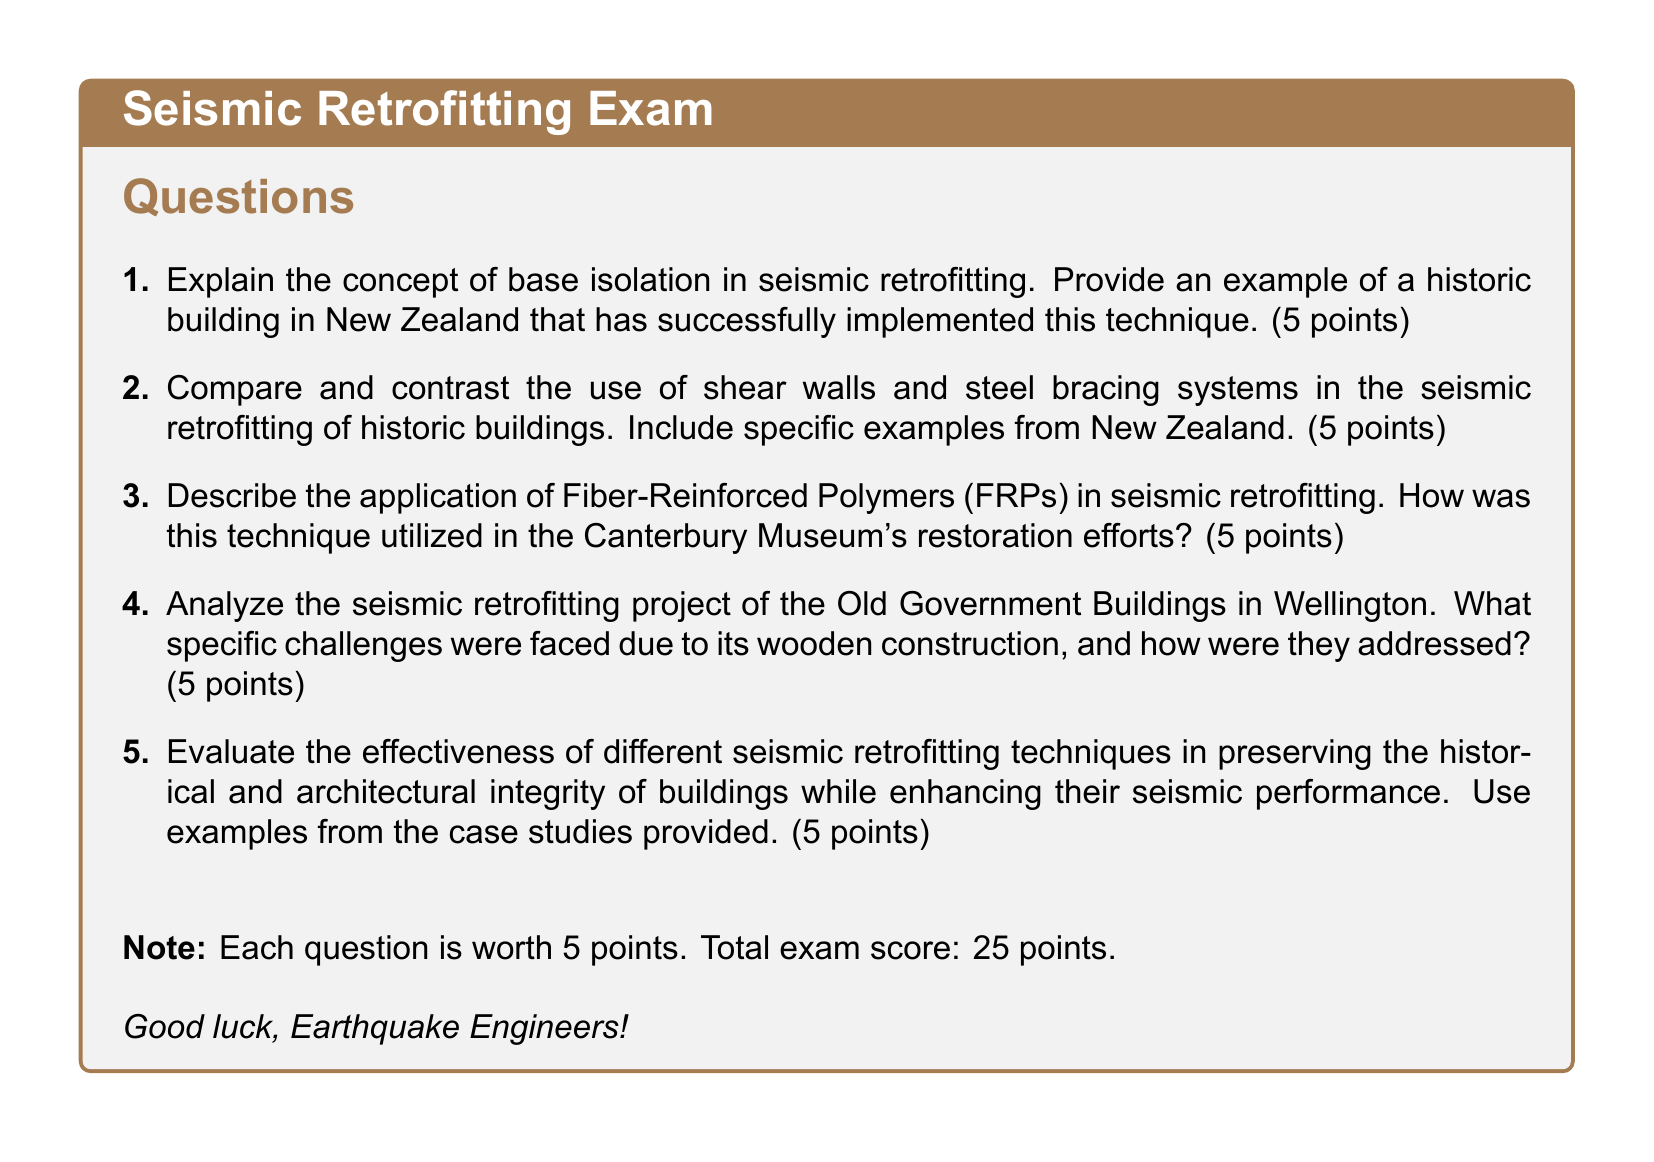What is the total score for the exam? The total exam score is calculated based on the points assigned to each question, which is 5 points per question for 5 questions, resulting in 25 points.
Answer: 25 points How many points is each question worth? Each question is indicated to be worth 5 points in the exam document.
Answer: 5 points What seismic retrofitting technique is used in the Canterbury Museum's restoration? The document mentions the application of Fiber-Reinforced Polymers (FRPs) in seismic retrofitting for the Canterbury Museum.
Answer: Fiber-Reinforced Polymers (FRPs) What is a challenge faced in retrofitting the Old Government Buildings? The document states that specific challenges were faced due to the wooden construction of the Old Government Buildings.
Answer: Wooden construction How many questions are in the exam? The document lists a total of 5 questions in the exam section.
Answer: 5 questions What color is used for headings in the document? The headings in the document are colored earth brown, as noted in the formatting section.
Answer: Earth brown What is the title of the exam? The exam is titled "Seismic Retrofitting Exam" as displayed at the top of the document.
Answer: Seismic Retrofitting Exam 